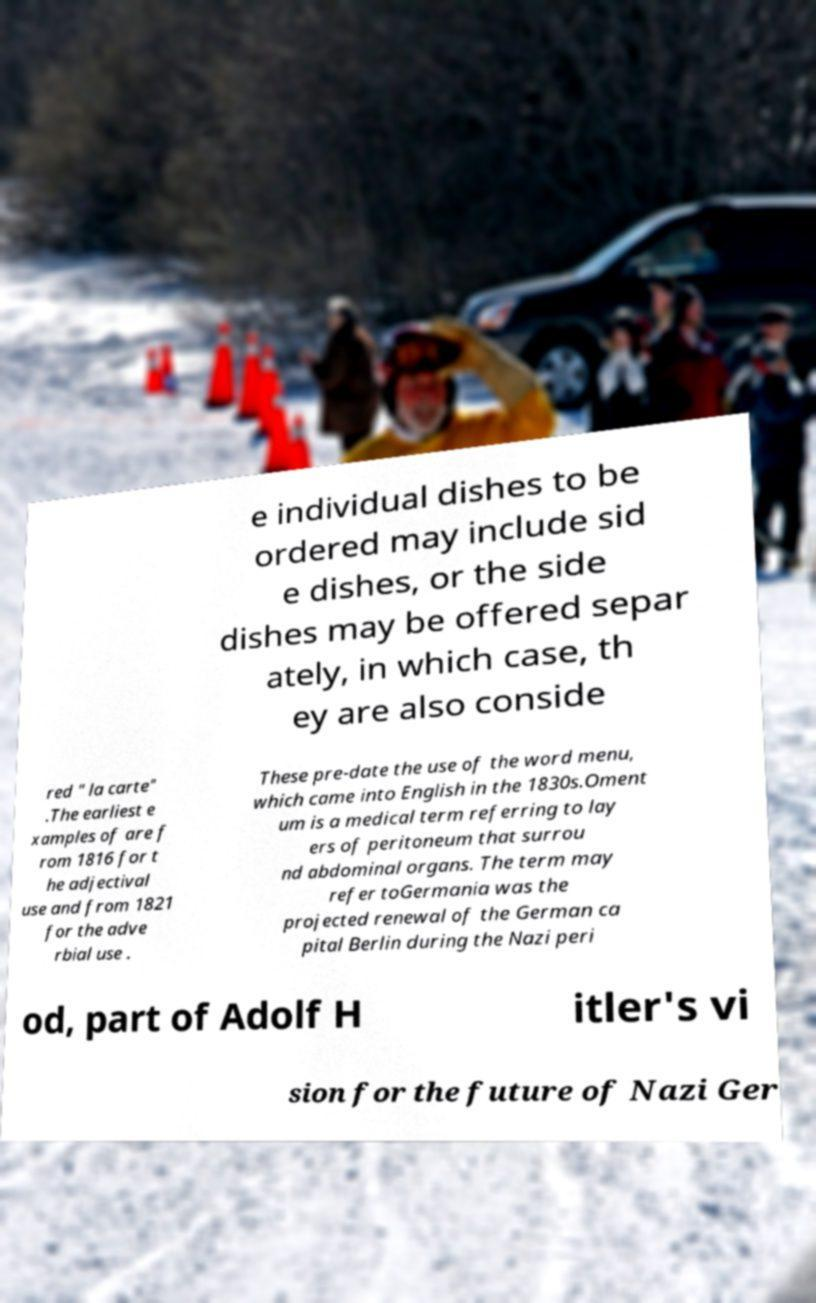I need the written content from this picture converted into text. Can you do that? e individual dishes to be ordered may include sid e dishes, or the side dishes may be offered separ ately, in which case, th ey are also conside red " la carte" .The earliest e xamples of are f rom 1816 for t he adjectival use and from 1821 for the adve rbial use . These pre-date the use of the word menu, which came into English in the 1830s.Oment um is a medical term referring to lay ers of peritoneum that surrou nd abdominal organs. The term may refer toGermania was the projected renewal of the German ca pital Berlin during the Nazi peri od, part of Adolf H itler's vi sion for the future of Nazi Ger 